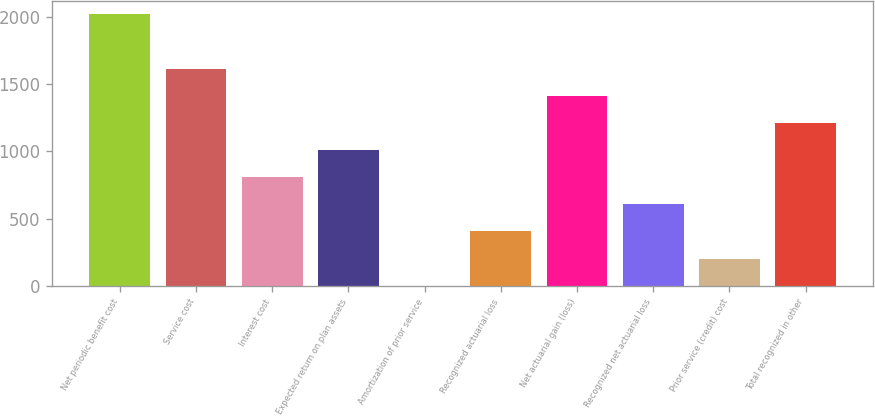Convert chart to OTSL. <chart><loc_0><loc_0><loc_500><loc_500><bar_chart><fcel>Net periodic benefit cost<fcel>Service cost<fcel>Interest cost<fcel>Expected return on plan assets<fcel>Amortization of prior service<fcel>Recognized actuarial loss<fcel>Net actuarial gain (loss)<fcel>Recognized net actuarial loss<fcel>Prior service (credit) cost<fcel>Total recognized in other<nl><fcel>2017<fcel>1613.8<fcel>807.4<fcel>1009<fcel>1<fcel>404.2<fcel>1412.2<fcel>605.8<fcel>202.6<fcel>1210.6<nl></chart> 